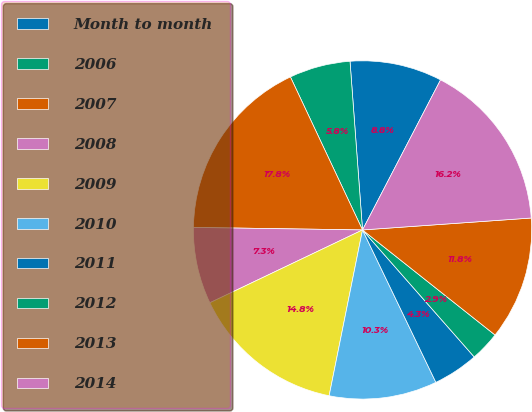Convert chart to OTSL. <chart><loc_0><loc_0><loc_500><loc_500><pie_chart><fcel>Month to month<fcel>2006<fcel>2007<fcel>2008<fcel>2009<fcel>2010<fcel>2011<fcel>2012<fcel>2013<fcel>2014<nl><fcel>8.81%<fcel>5.83%<fcel>17.75%<fcel>7.32%<fcel>14.75%<fcel>10.3%<fcel>4.34%<fcel>2.85%<fcel>11.79%<fcel>16.24%<nl></chart> 